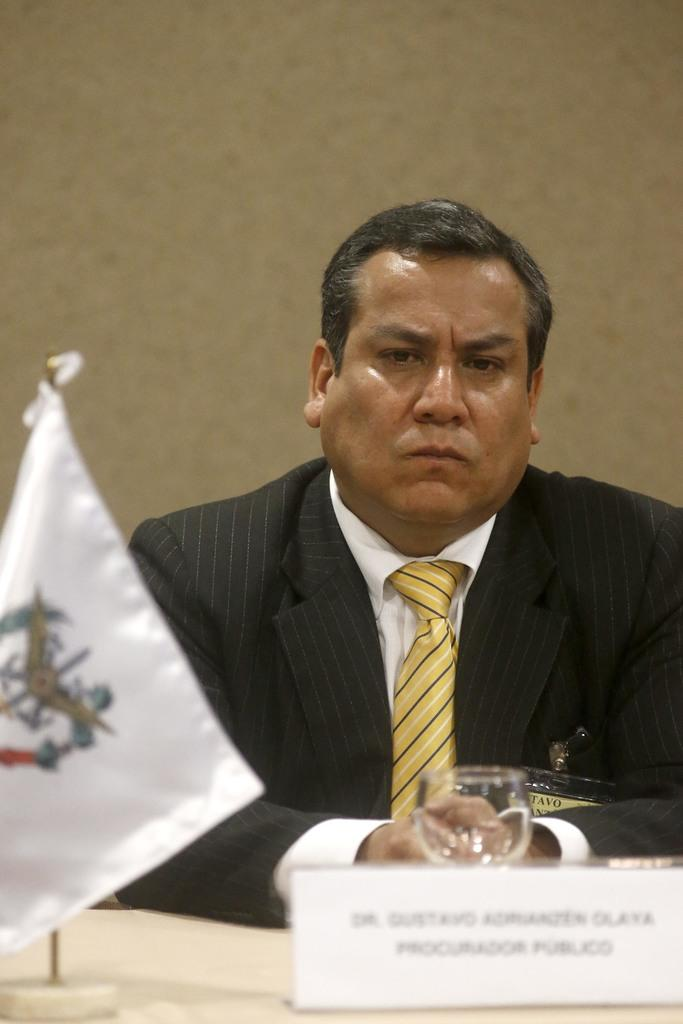What is the appearance of the man in the image? The man in the image is wearing a suit. What is located in front of the man? There is a table in front of the man. What items can be seen on the table? There is a small flag, a name board, and a glass on the table. What is visible in the background of the image? There is a wall in the background of the image. What type of sea creature can be seen swimming near the man in the image? There is no sea creature present in the image; it is set indoors with a man, a table, and a wall in the background. 